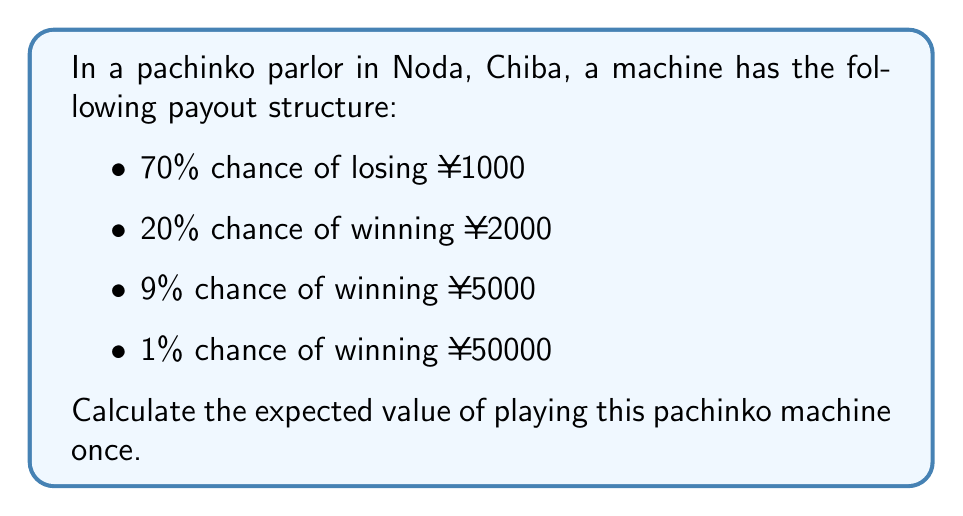Give your solution to this math problem. To calculate the expected value, we need to multiply each possible outcome by its probability and then sum these products.

Let's break it down step-by-step:

1) Losing ¥1000 with 70% probability:
   $0.70 \times (-1000) = -700$

2) Winning ¥2000 with 20% probability:
   $0.20 \times 2000 = 400$

3) Winning ¥5000 with 9% probability:
   $0.09 \times 5000 = 450$

4) Winning ¥50000 with 1% probability:
   $0.01 \times 50000 = 500$

Now, we sum all these values:

$$E = -700 + 400 + 450 + 500 = 650$$

Therefore, the expected value of playing this pachinko machine once is ¥650.
Answer: ¥650 